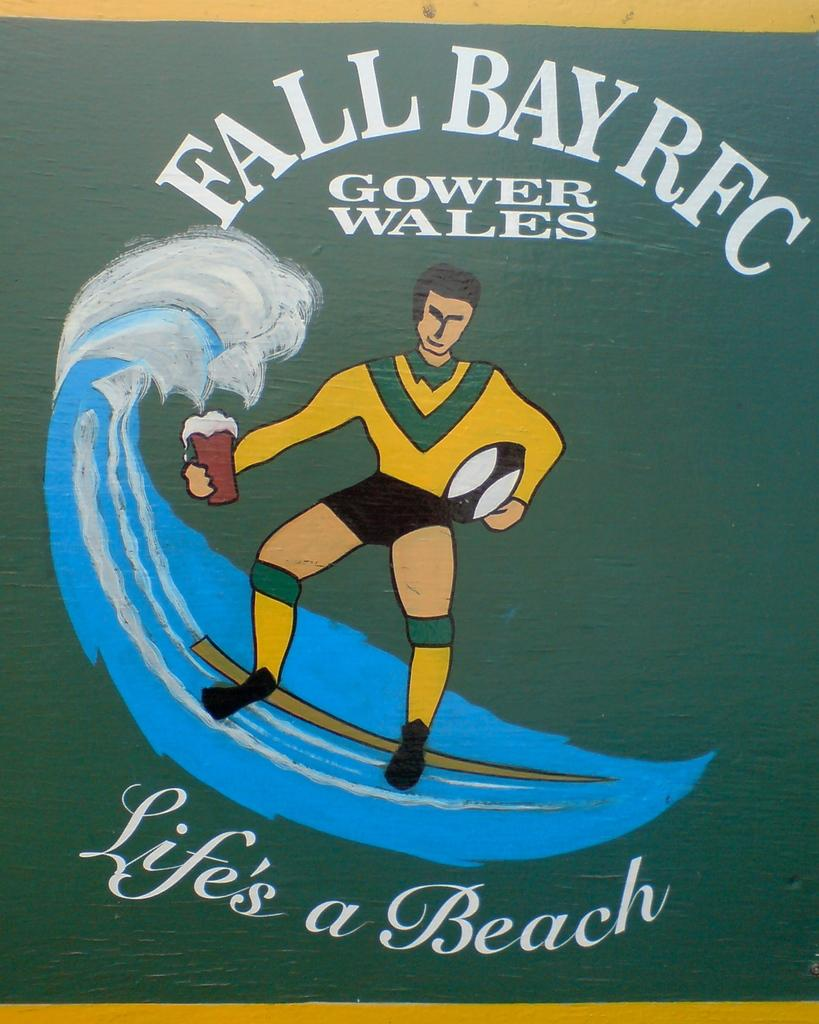What type of visual is the image in question? The image is a poster. What is depicted on the poster? There is a person's image on the poster. What is the person holding in the image? The person is holding a cup and a ball. Can you describe the background of the image? There is water visible in the image. What is written on the poster? There is text written at the top and bottom of the poster. What day of the week is the person's mom mentioned in the text at the bottom of the poster? There is no mention of a day of the week or the person's mom in the text at the bottom of the poster. 